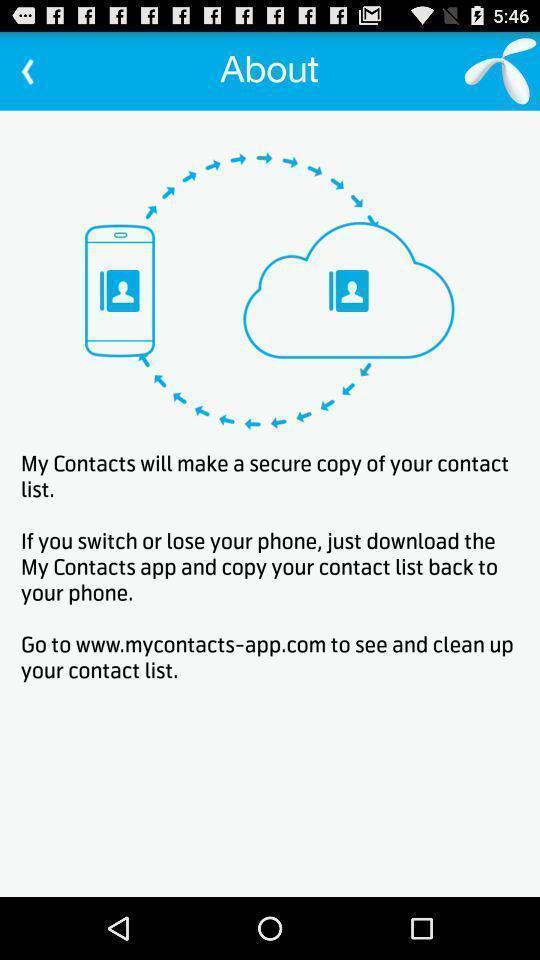Please provide a description for this image. Page showing general information on contacts app. 